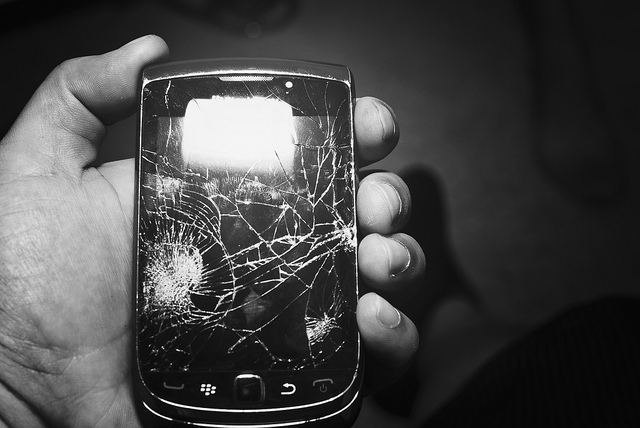What make is this phone? The phone in the image is a Blackberry, recognizable by its distinctive keyboard layout and shape, typical of many models produced by the brand. 